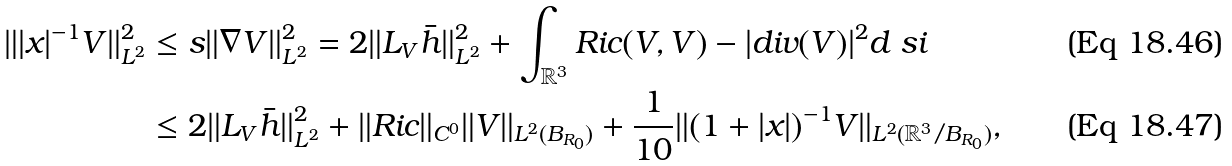<formula> <loc_0><loc_0><loc_500><loc_500>\| | x | ^ { - 1 } V \| _ { L ^ { 2 } } ^ { 2 } & \leq s \| \nabla V \| _ { L ^ { 2 } } ^ { 2 } = 2 \| L _ { V } \bar { h } \| _ { L ^ { 2 } } ^ { 2 } + \int _ { \mathbb { R } ^ { 3 } } R i c ( V , V ) - | d i v ( V ) | ^ { 2 } d \ s i \\ & \leq 2 \| L _ { V } \bar { h } \| _ { L ^ { 2 } } ^ { 2 } + \| R i c \| _ { C ^ { 0 } } \| V \| _ { L ^ { 2 } ( B _ { R _ { 0 } } ) } + \frac { 1 } { 1 0 } \| ( 1 + | x | ) ^ { - 1 } V \| _ { L ^ { 2 } ( \mathbb { R } ^ { 3 } / B _ { R _ { 0 } } ) } ,</formula> 